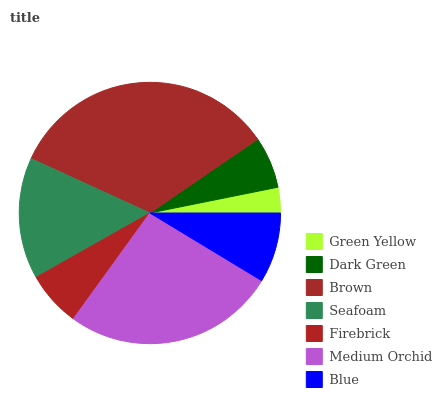Is Green Yellow the minimum?
Answer yes or no. Yes. Is Brown the maximum?
Answer yes or no. Yes. Is Dark Green the minimum?
Answer yes or no. No. Is Dark Green the maximum?
Answer yes or no. No. Is Dark Green greater than Green Yellow?
Answer yes or no. Yes. Is Green Yellow less than Dark Green?
Answer yes or no. Yes. Is Green Yellow greater than Dark Green?
Answer yes or no. No. Is Dark Green less than Green Yellow?
Answer yes or no. No. Is Blue the high median?
Answer yes or no. Yes. Is Blue the low median?
Answer yes or no. Yes. Is Firebrick the high median?
Answer yes or no. No. Is Green Yellow the low median?
Answer yes or no. No. 